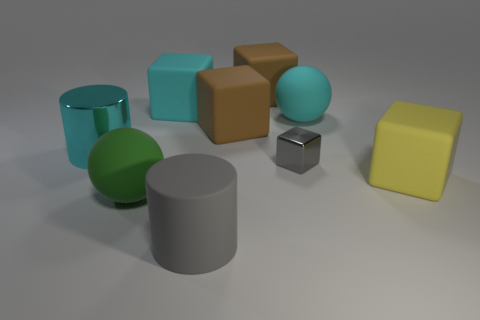Are there any blue metal spheres of the same size as the gray cube?
Provide a short and direct response. No. There is a cyan rubber block; is its size the same as the cylinder that is to the left of the large cyan rubber block?
Provide a succinct answer. Yes. Is the number of cyan metal things in front of the large green matte thing the same as the number of cyan blocks in front of the gray cube?
Make the answer very short. Yes. The object that is the same color as the rubber cylinder is what shape?
Offer a terse response. Cube. There is a cylinder that is in front of the large yellow matte object; what is its material?
Give a very brief answer. Rubber. Is the size of the green matte object the same as the cyan cylinder?
Provide a short and direct response. Yes. Is the number of cyan metallic cylinders that are in front of the tiny shiny cube greater than the number of tiny objects?
Provide a succinct answer. No. There is a sphere that is the same material as the green object; what size is it?
Ensure brevity in your answer.  Large. There is a big cyan shiny cylinder; are there any matte objects in front of it?
Make the answer very short. Yes. Is the shape of the yellow object the same as the large gray rubber object?
Ensure brevity in your answer.  No. 